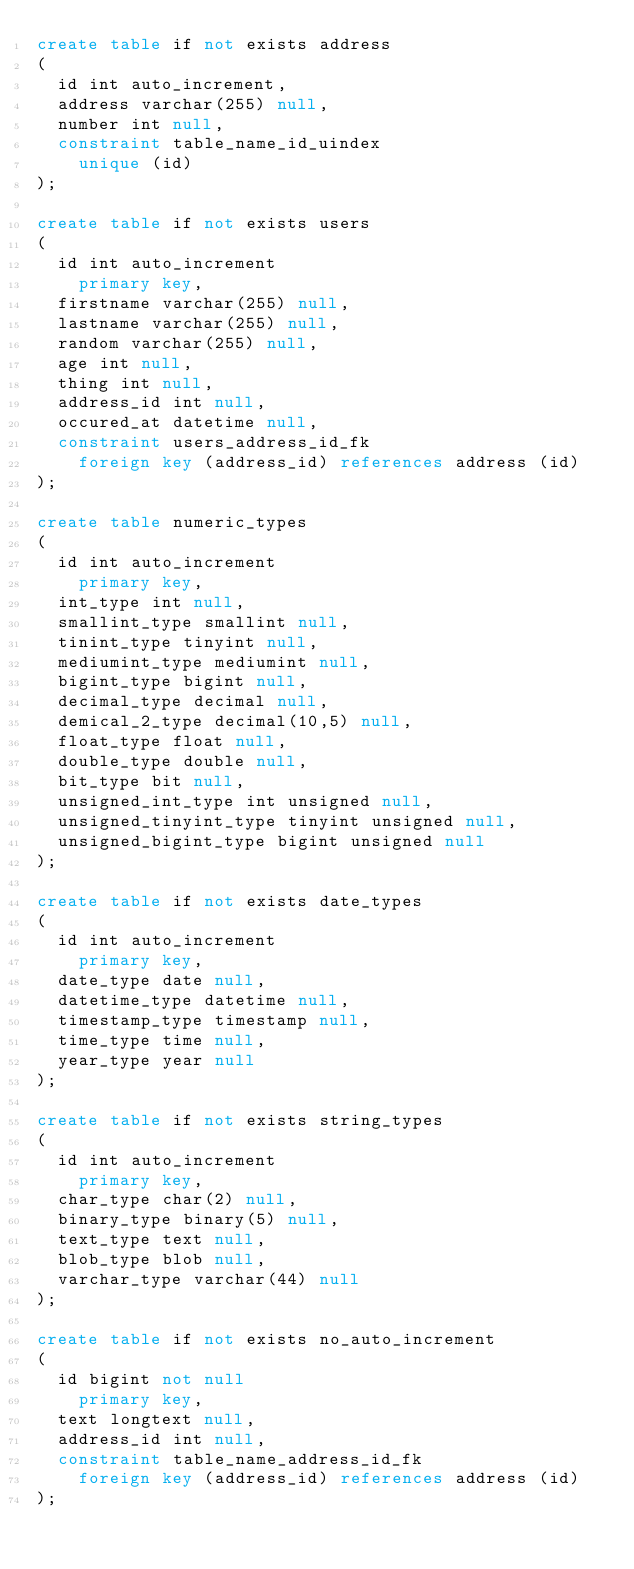Convert code to text. <code><loc_0><loc_0><loc_500><loc_500><_SQL_>create table if not exists address
(
	id int auto_increment,
	address varchar(255) null,
	number int null,
	constraint table_name_id_uindex
		unique (id)
);

create table if not exists users
(
	id int auto_increment
		primary key,
	firstname varchar(255) null,
	lastname varchar(255) null,
	random varchar(255) null,
	age int null,
	thing int null,
	address_id int null,
	occured_at datetime null,
	constraint users_address_id_fk
		foreign key (address_id) references address (id)
);

create table numeric_types
(
	id int auto_increment
		primary key,
	int_type int null,
	smallint_type smallint null,
	tinint_type tinyint null,
	mediumint_type mediumint null,
	bigint_type bigint null,
	decimal_type decimal null,
	demical_2_type decimal(10,5) null,
	float_type float null,
	double_type double null,
	bit_type bit null,
	unsigned_int_type int unsigned null,
	unsigned_tinyint_type tinyint unsigned null,
	unsigned_bigint_type bigint unsigned null
);

create table if not exists date_types
(
	id int auto_increment
		primary key,
	date_type date null,
	datetime_type datetime null,
	timestamp_type timestamp null,
	time_type time null,
	year_type year null
);

create table if not exists string_types
(
	id int auto_increment
		primary key,
	char_type char(2) null,
	binary_type binary(5) null,
	text_type text null,
	blob_type blob null,
	varchar_type varchar(44) null
);

create table if not exists no_auto_increment
(
	id bigint not null
		primary key,
	text longtext null,
	address_id int null,
	constraint table_name_address_id_fk
		foreign key (address_id) references address (id)
);</code> 